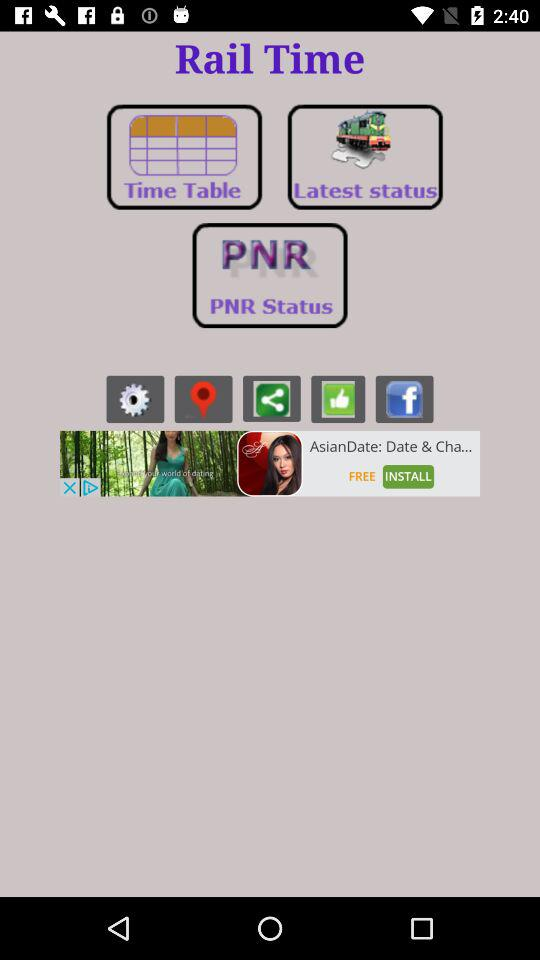What is the application name? The application name is "Rail Time". 